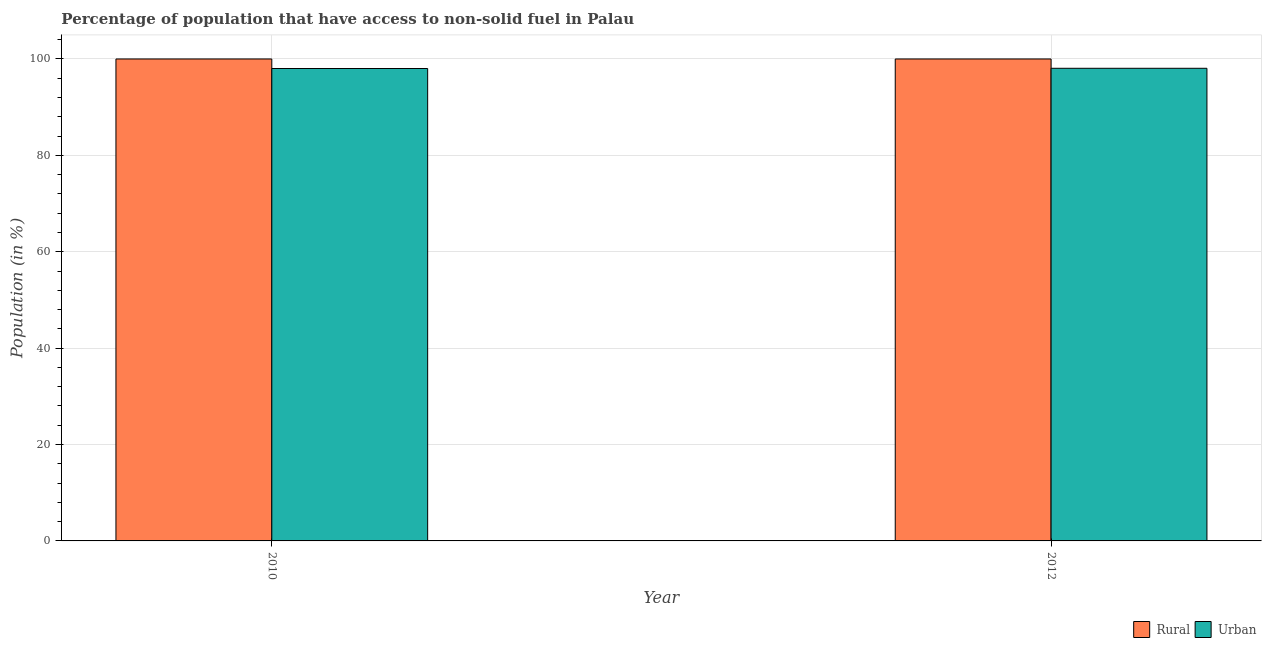Are the number of bars per tick equal to the number of legend labels?
Keep it short and to the point. Yes. How many bars are there on the 1st tick from the left?
Offer a terse response. 2. What is the label of the 2nd group of bars from the left?
Provide a succinct answer. 2012. In how many cases, is the number of bars for a given year not equal to the number of legend labels?
Keep it short and to the point. 0. What is the urban population in 2010?
Ensure brevity in your answer.  98.02. Across all years, what is the maximum rural population?
Your answer should be very brief. 100. Across all years, what is the minimum urban population?
Offer a terse response. 98.02. What is the total urban population in the graph?
Give a very brief answer. 196.09. What is the difference between the urban population in 2010 and that in 2012?
Your answer should be very brief. -0.05. What is the difference between the urban population in 2012 and the rural population in 2010?
Offer a very short reply. 0.05. What is the average urban population per year?
Give a very brief answer. 98.04. In how many years, is the urban population greater than 92 %?
Ensure brevity in your answer.  2. Is the rural population in 2010 less than that in 2012?
Keep it short and to the point. No. In how many years, is the urban population greater than the average urban population taken over all years?
Your answer should be compact. 1. What does the 2nd bar from the left in 2010 represents?
Offer a terse response. Urban. What does the 2nd bar from the right in 2010 represents?
Provide a short and direct response. Rural. How many years are there in the graph?
Provide a short and direct response. 2. What is the difference between two consecutive major ticks on the Y-axis?
Ensure brevity in your answer.  20. Are the values on the major ticks of Y-axis written in scientific E-notation?
Make the answer very short. No. What is the title of the graph?
Give a very brief answer. Percentage of population that have access to non-solid fuel in Palau. What is the label or title of the Y-axis?
Give a very brief answer. Population (in %). What is the Population (in %) of Rural in 2010?
Ensure brevity in your answer.  100. What is the Population (in %) in Urban in 2010?
Make the answer very short. 98.02. What is the Population (in %) in Rural in 2012?
Keep it short and to the point. 100. What is the Population (in %) in Urban in 2012?
Offer a terse response. 98.07. Across all years, what is the maximum Population (in %) of Urban?
Provide a succinct answer. 98.07. Across all years, what is the minimum Population (in %) of Urban?
Offer a terse response. 98.02. What is the total Population (in %) of Urban in the graph?
Ensure brevity in your answer.  196.09. What is the difference between the Population (in %) of Rural in 2010 and that in 2012?
Provide a succinct answer. 0. What is the difference between the Population (in %) in Urban in 2010 and that in 2012?
Provide a succinct answer. -0.05. What is the difference between the Population (in %) in Rural in 2010 and the Population (in %) in Urban in 2012?
Offer a terse response. 1.93. What is the average Population (in %) of Rural per year?
Give a very brief answer. 100. What is the average Population (in %) in Urban per year?
Offer a terse response. 98.04. In the year 2010, what is the difference between the Population (in %) in Rural and Population (in %) in Urban?
Your answer should be very brief. 1.98. In the year 2012, what is the difference between the Population (in %) of Rural and Population (in %) of Urban?
Offer a very short reply. 1.93. What is the ratio of the Population (in %) of Urban in 2010 to that in 2012?
Your response must be concise. 1. What is the difference between the highest and the second highest Population (in %) in Urban?
Provide a short and direct response. 0.05. What is the difference between the highest and the lowest Population (in %) in Rural?
Your answer should be very brief. 0. What is the difference between the highest and the lowest Population (in %) of Urban?
Your answer should be very brief. 0.05. 